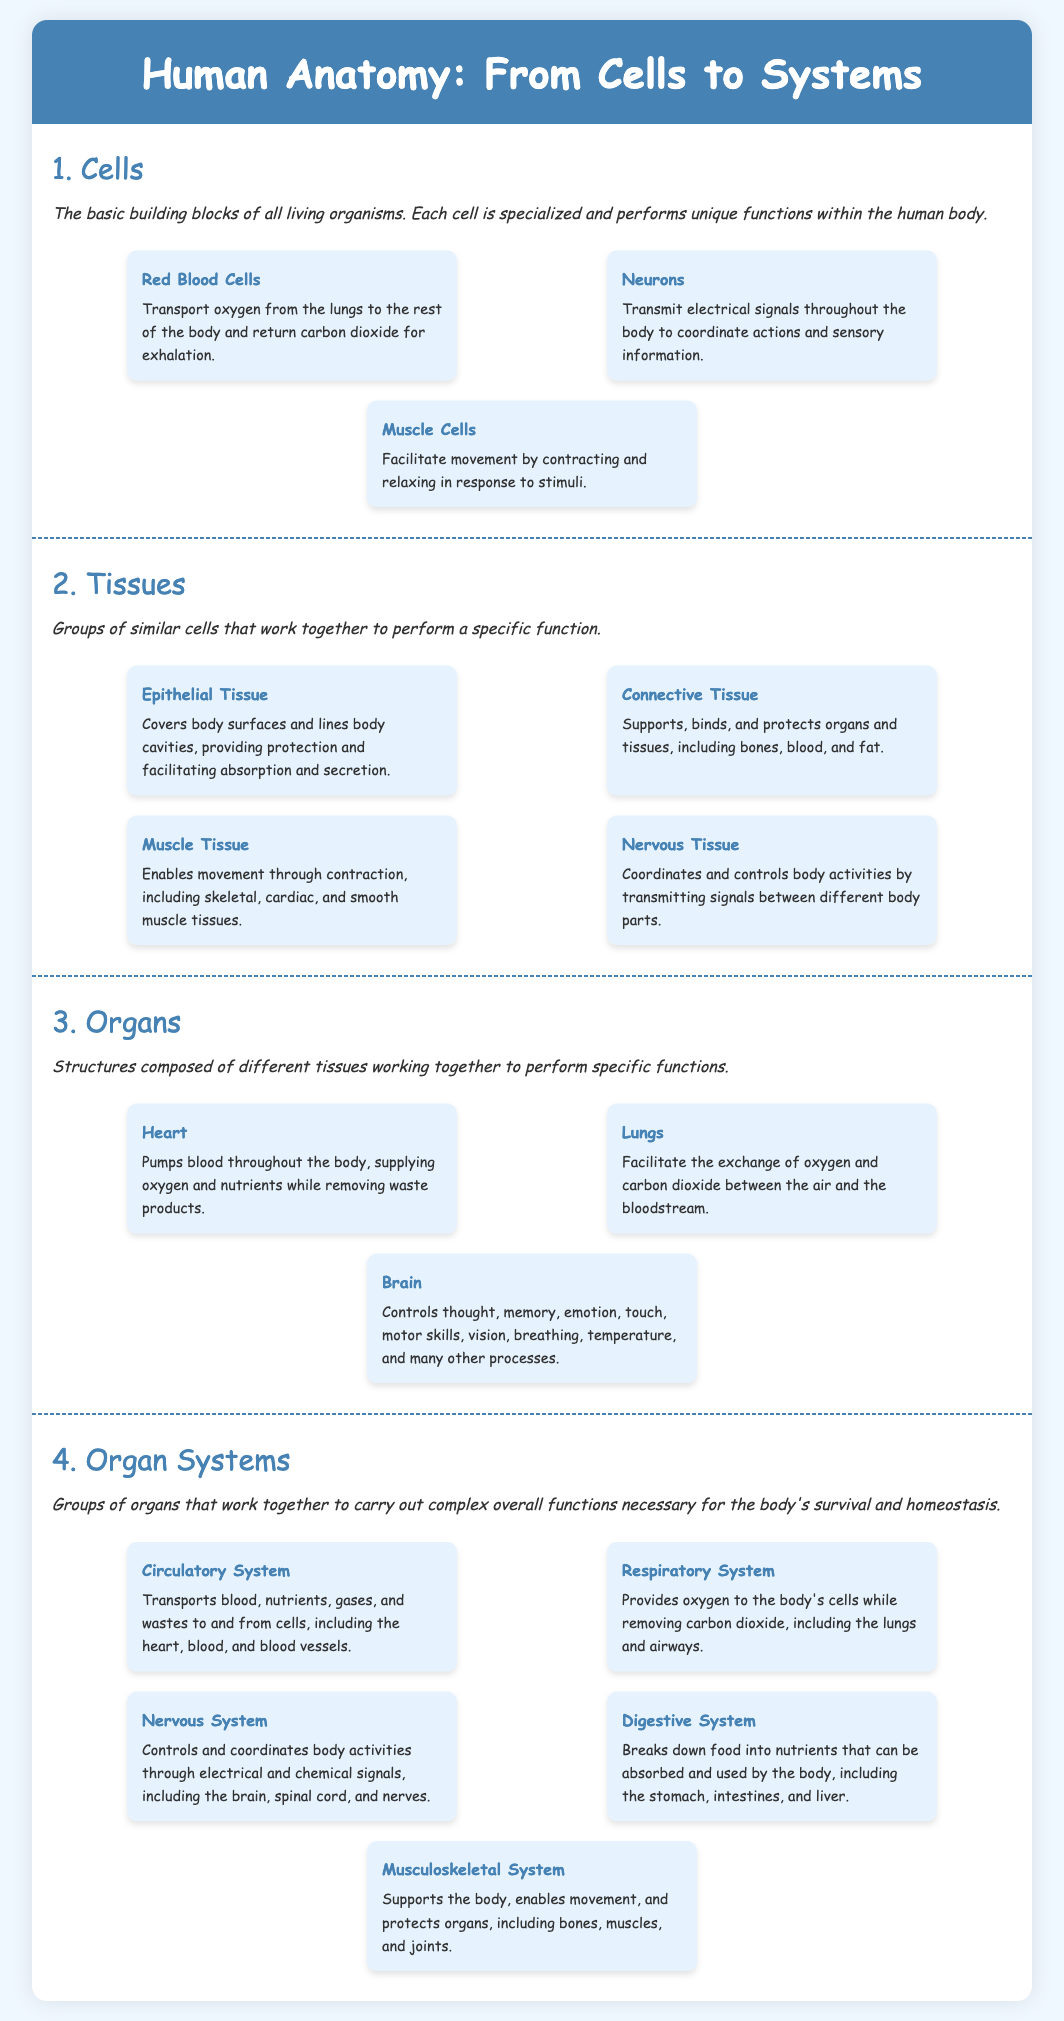What are the basic building blocks of all living organisms? The document states that cells are the basic building blocks of all living organisms.
Answer: Cells How many types of muscle tissues are mentioned? The document lists skeletal, cardiac, and smooth muscle tissues as types of muscle tissues, making the count three.
Answer: Three What organ is responsible for pumping blood? It specifies that the heart pumps blood throughout the body.
Answer: Heart Which system removes carbon dioxide from the body? The respiratory system is responsible for removing carbon dioxide from the body.
Answer: Respiratory System What type of tissue covers body surfaces? Epithelial tissue is noted for covering body surfaces.
Answer: Epithelial Tissue What organ system includes bones and muscles? The document indicates that the musculoskeletal system supports the body and enables movement.
Answer: Musculoskeletal System How many examples of organ systems are listed? The document includes five examples of organ systems.
Answer: Five What is the main function of neurons? Neurons transmit electrical signals throughout the body for coordination of actions and sensory information.
Answer: Transmit electrical signals What type of cells facilitate movement? The document states that muscle cells facilitate movement.
Answer: Muscle Cells 